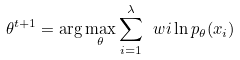<formula> <loc_0><loc_0><loc_500><loc_500>\theta ^ { t + 1 } = \arg \max _ { \theta } \sum _ { i = 1 } ^ { \lambda } \ w i \ln p _ { \theta } ( x _ { i } )</formula> 